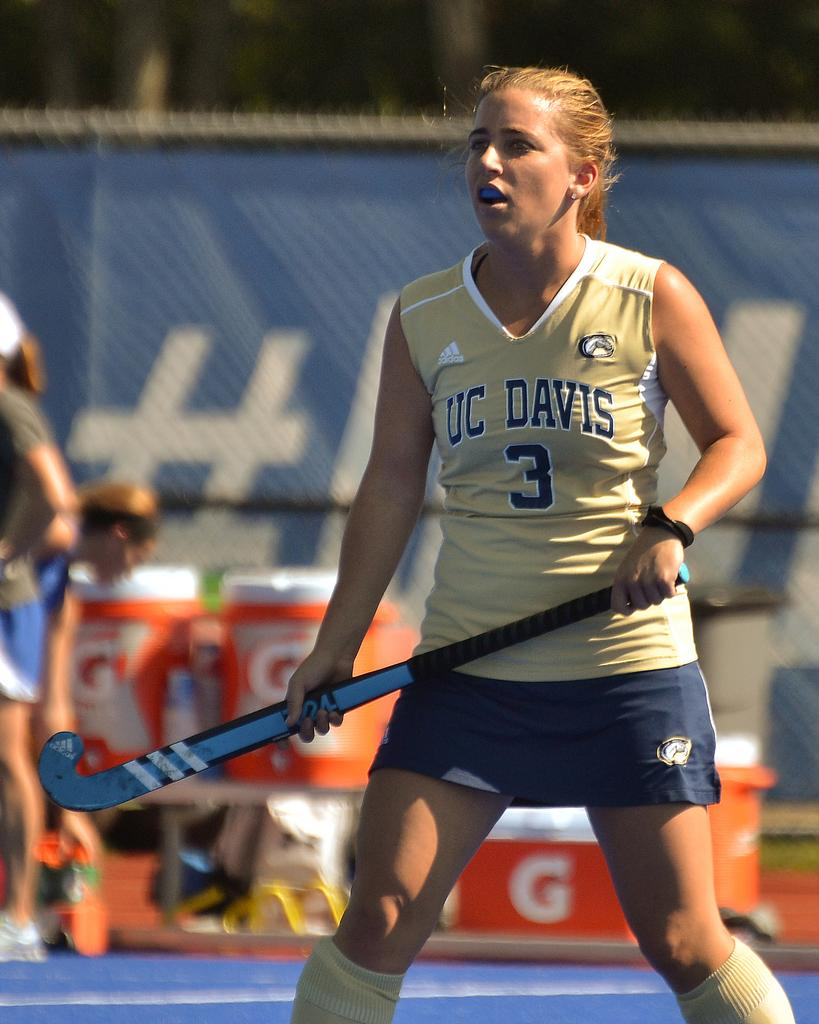<image>
Describe the image concisely. A girl has a shirt with the number 3 on the front of it. 